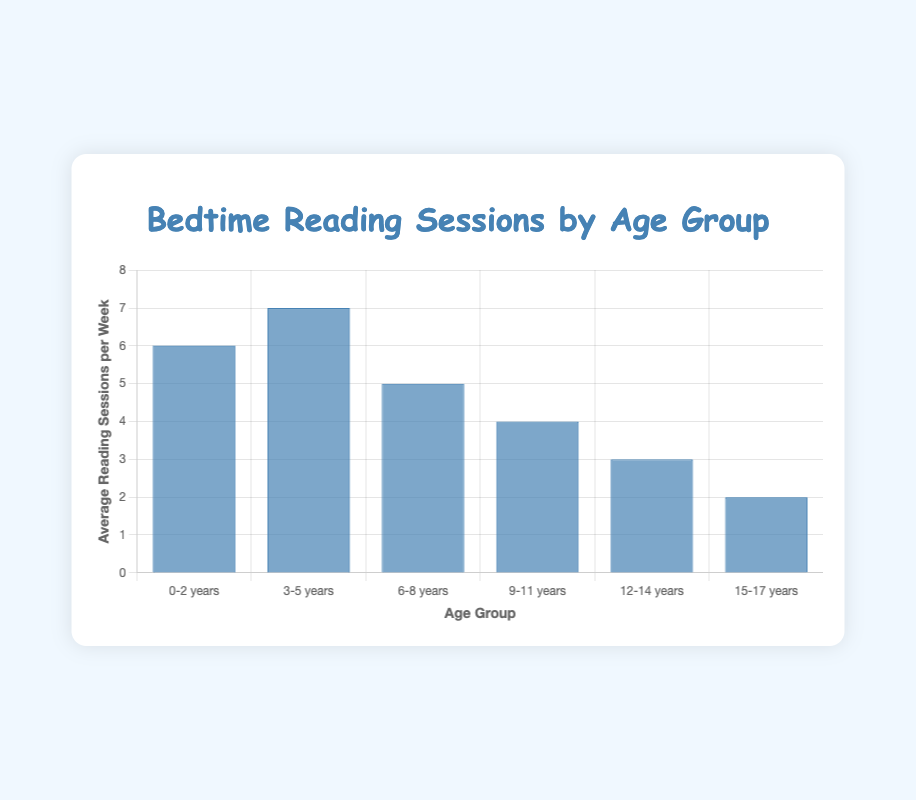How many more reading sessions per week do the 3-5 years group have compared to the 15-17 years group? The 3-5 years group has 7 sessions per week, while the 15-17 years group has 2 sessions per week. The difference is calculated as 7 - 2 = 5.
Answer: 5 Which age group has the highest average number of reading sessions per week? By looking at the heights of the bars, the 3-5 years group has the tallest bar, indicating the highest number of reading sessions per week at 7.
Answer: 3-5 years How many reading sessions per week are there on average for the 0-2 and 6-8 years age groups combined? The 0-2 years group has 6 sessions per week, and the 6-8 years group has 5 sessions per week. The total is 6 + 5 = 11, and the combined average is 11/2 = 5.5.
Answer: 5.5 Is there a downward trend in the frequency of reading sessions per week as the age groups increase? Yes, as the age groups go from younger to older (0-2 to 15-17), the number of reading sessions per week decreases consistently.
Answer: Yes What is the difference in reading sessions per week between the age groups with the highest and lowest frequencies? The highest frequency (3-5 years) is 7 sessions per week, and the lowest frequency (15-17 years) is 2 sessions per week. The difference is 7 - 2 = 5.
Answer: 5 What is the total average number of reading sessions per week for all age groups combined? The total number of reading sessions per week for all age groups combined is 6 + 7 + 5 + 4 + 3 + 2 = 27. There are 6 age groups, so the overall average is 27/6 = 4.5.
Answer: 4.5 Which two age groups have the closest average number of reading sessions per week? By comparing the numbers, the 12-14 years (3) and 15-17 years (2) groups have the smallest difference of 1 session per week.
Answer: 12-14 years and 15-17 years 